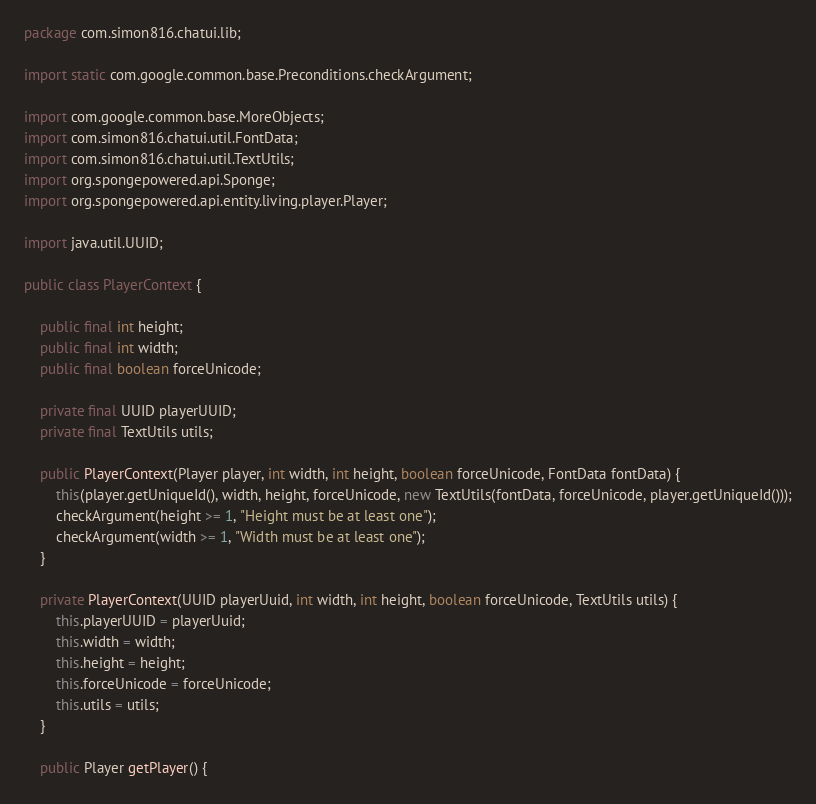Convert code to text. <code><loc_0><loc_0><loc_500><loc_500><_Java_>package com.simon816.chatui.lib;

import static com.google.common.base.Preconditions.checkArgument;

import com.google.common.base.MoreObjects;
import com.simon816.chatui.util.FontData;
import com.simon816.chatui.util.TextUtils;
import org.spongepowered.api.Sponge;
import org.spongepowered.api.entity.living.player.Player;

import java.util.UUID;

public class PlayerContext {

    public final int height;
    public final int width;
    public final boolean forceUnicode;

    private final UUID playerUUID;
    private final TextUtils utils;

    public PlayerContext(Player player, int width, int height, boolean forceUnicode, FontData fontData) {
        this(player.getUniqueId(), width, height, forceUnicode, new TextUtils(fontData, forceUnicode, player.getUniqueId()));
        checkArgument(height >= 1, "Height must be at least one");
        checkArgument(width >= 1, "Width must be at least one");
    }

    private PlayerContext(UUID playerUuid, int width, int height, boolean forceUnicode, TextUtils utils) {
        this.playerUUID = playerUuid;
        this.width = width;
        this.height = height;
        this.forceUnicode = forceUnicode;
        this.utils = utils;
    }

    public Player getPlayer() {</code> 